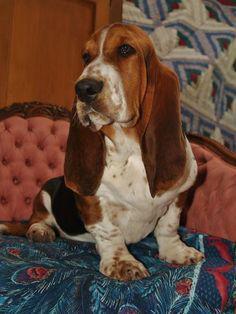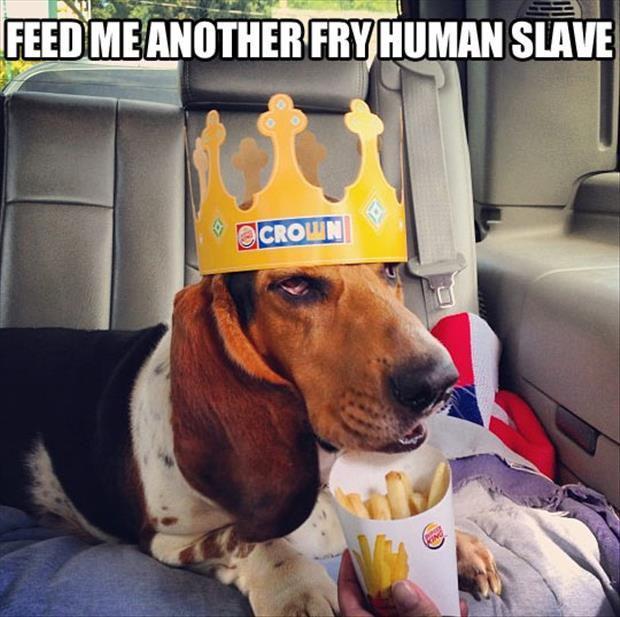The first image is the image on the left, the second image is the image on the right. For the images shown, is this caption "An image shows at least one dog wearing a hat associated with an ingestible product that is also pictured." true? Answer yes or no. Yes. The first image is the image on the left, the second image is the image on the right. Considering the images on both sides, is "There are two dogs in total." valid? Answer yes or no. Yes. 